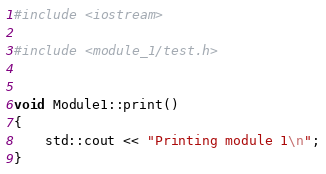<code> <loc_0><loc_0><loc_500><loc_500><_C++_>#include <iostream>

#include <module_1/test.h>


void Module1::print()
{
    std::cout << "Printing module 1\n";
}</code> 